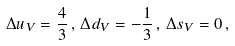<formula> <loc_0><loc_0><loc_500><loc_500>\Delta u _ { V } = \frac { 4 } { 3 } \, , \, \Delta d _ { V } = - \frac { 1 } { 3 } \, , \, \Delta s _ { V } = 0 \, ,</formula> 